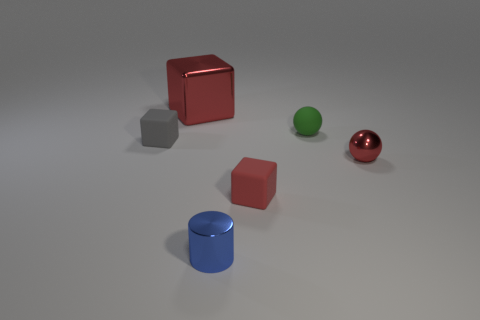What number of other objects are there of the same color as the metallic block?
Your answer should be very brief. 2. The small block that is on the right side of the tiny rubber thing that is to the left of the small rubber block on the right side of the large shiny object is made of what material?
Your response must be concise. Rubber. What number of cylinders are either green metallic things or large shiny objects?
Offer a very short reply. 0. Is there anything else that has the same size as the matte sphere?
Provide a short and direct response. Yes. There is a ball that is behind the rubber block that is to the left of the tiny blue metal cylinder; what number of red things are behind it?
Make the answer very short. 1. Is the blue metal thing the same shape as the gray rubber object?
Keep it short and to the point. No. Do the red block in front of the small gray matte object and the red cube left of the cylinder have the same material?
Your answer should be very brief. No. How many things are either tiny things in front of the metal ball or matte things behind the gray rubber thing?
Your answer should be very brief. 3. Is there anything else that is the same shape as the gray rubber object?
Offer a terse response. Yes. What number of tiny brown rubber spheres are there?
Offer a very short reply. 0. 